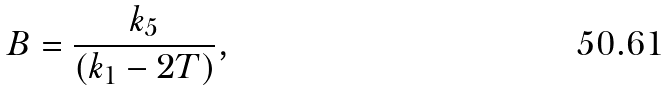Convert formula to latex. <formula><loc_0><loc_0><loc_500><loc_500>B = \frac { k _ { 5 } } { ( k _ { 1 } - 2 T ) } ,</formula> 